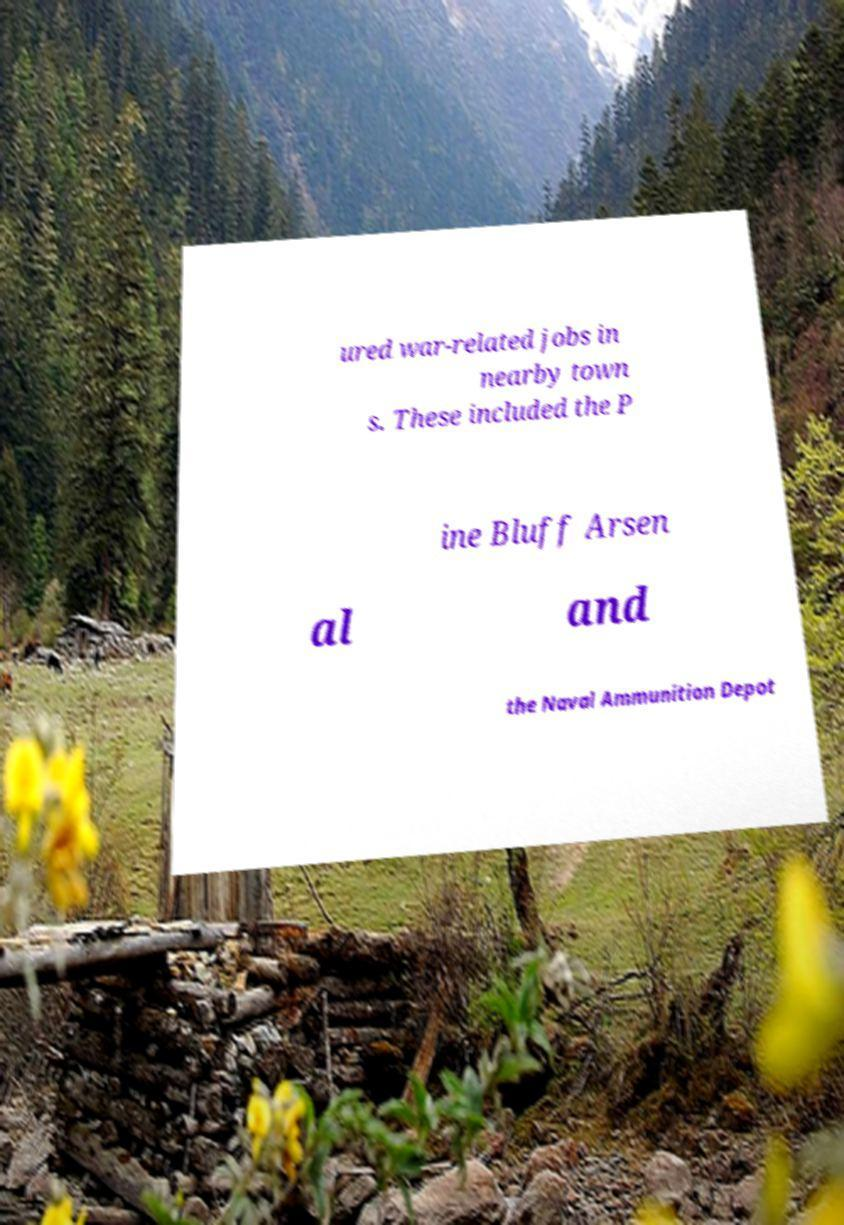Please identify and transcribe the text found in this image. ured war-related jobs in nearby town s. These included the P ine Bluff Arsen al and the Naval Ammunition Depot 